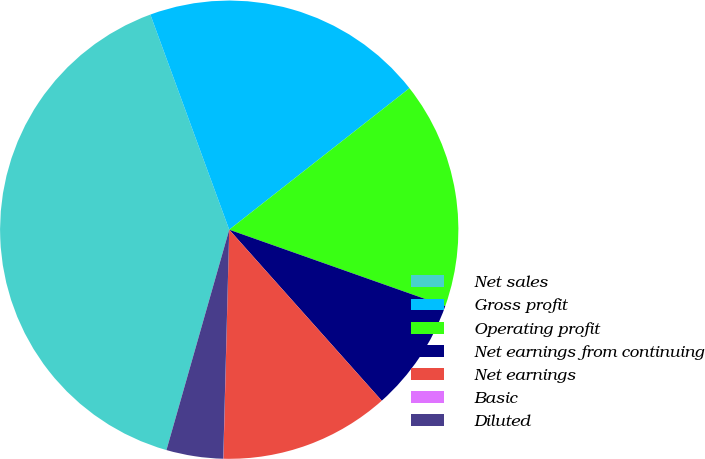<chart> <loc_0><loc_0><loc_500><loc_500><pie_chart><fcel>Net sales<fcel>Gross profit<fcel>Operating profit<fcel>Net earnings from continuing<fcel>Net earnings<fcel>Basic<fcel>Diluted<nl><fcel>39.99%<fcel>20.0%<fcel>16.0%<fcel>8.0%<fcel>12.0%<fcel>0.01%<fcel>4.0%<nl></chart> 